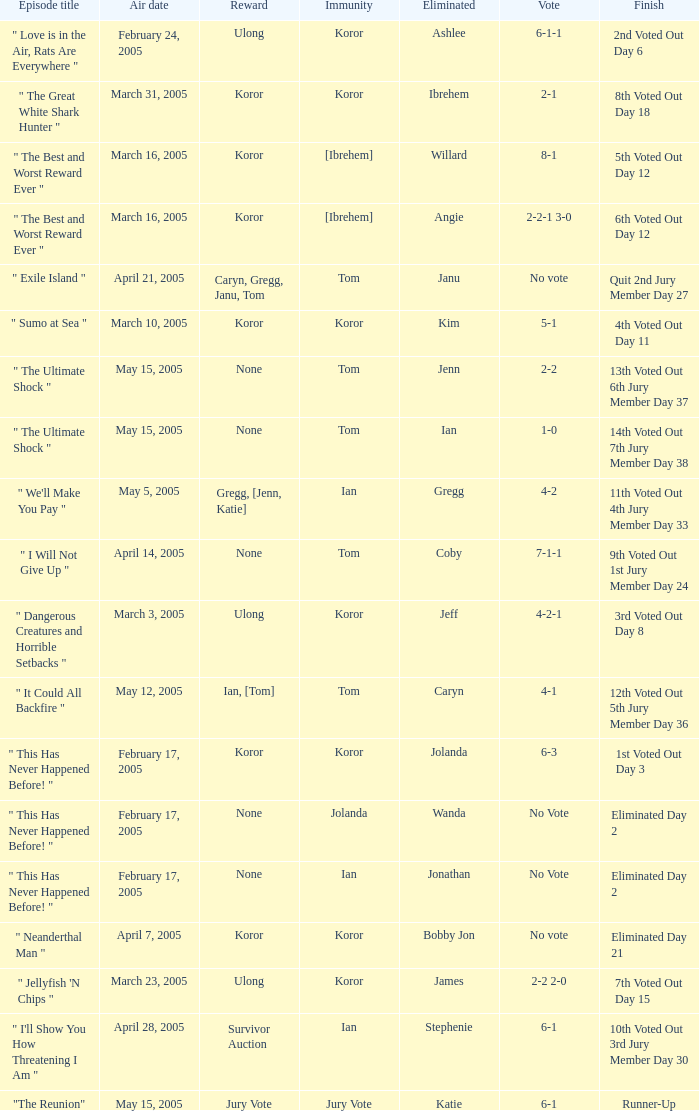How many votes were taken when the outcome was "6th voted out day 12"? 1.0. 